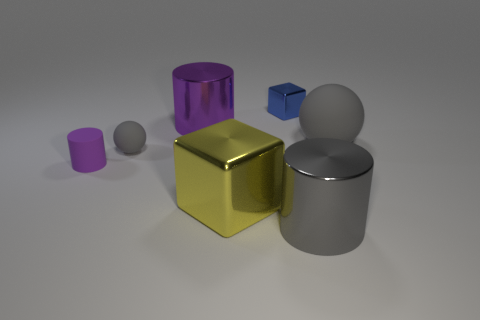Subtract all cyan spheres. Subtract all blue cylinders. How many spheres are left? 2 Add 1 brown matte cylinders. How many objects exist? 8 Subtract all cubes. How many objects are left? 5 Subtract all purple objects. Subtract all purple metallic cylinders. How many objects are left? 4 Add 4 metal things. How many metal things are left? 8 Add 5 large green metal things. How many large green metal things exist? 5 Subtract 0 red balls. How many objects are left? 7 